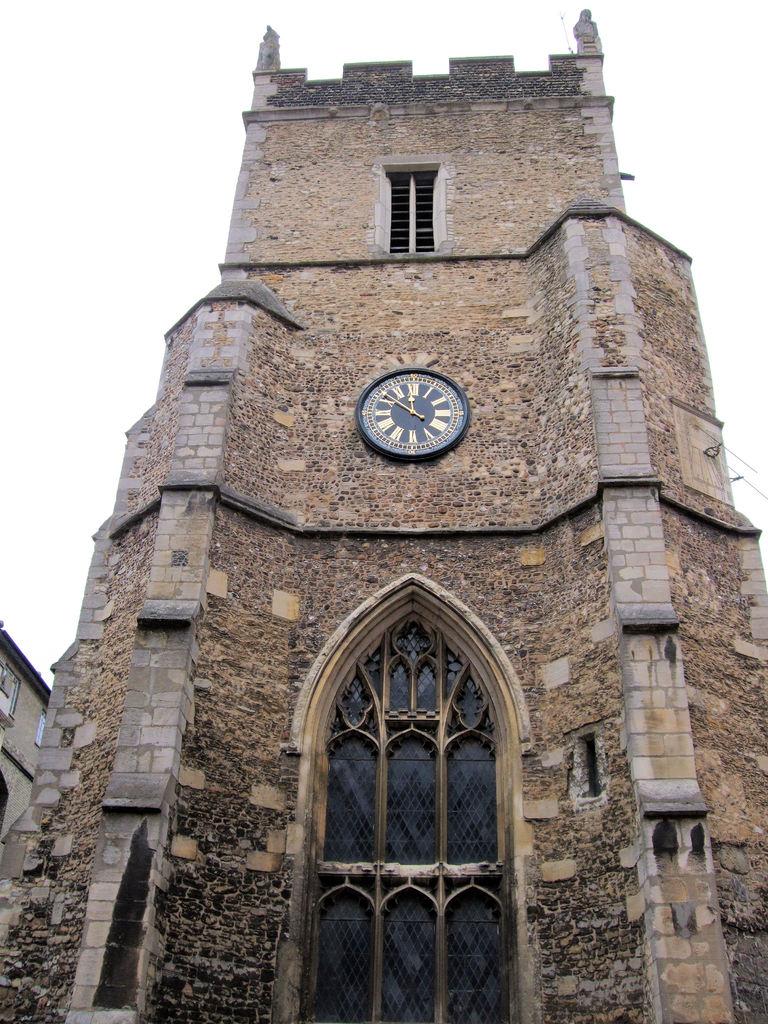What time is it?
Ensure brevity in your answer.  11:52. 